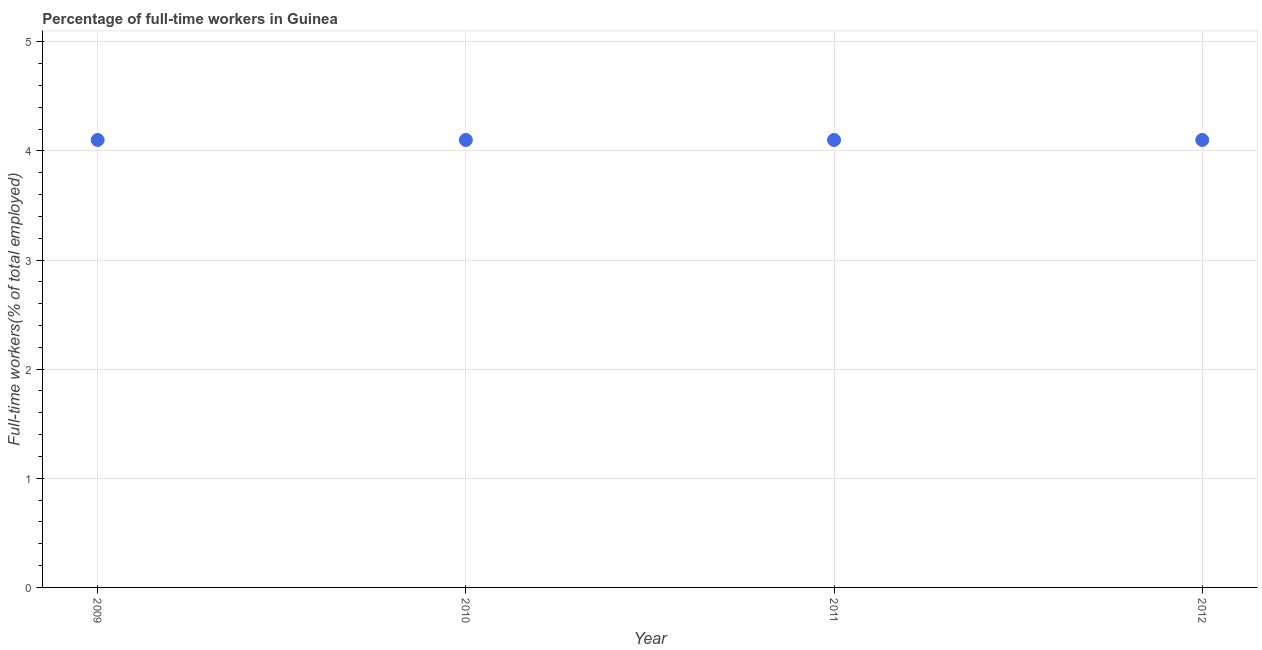What is the percentage of full-time workers in 2011?
Give a very brief answer. 4.1. Across all years, what is the maximum percentage of full-time workers?
Your answer should be compact. 4.1. Across all years, what is the minimum percentage of full-time workers?
Give a very brief answer. 4.1. What is the sum of the percentage of full-time workers?
Provide a short and direct response. 16.4. What is the average percentage of full-time workers per year?
Offer a terse response. 4.1. What is the median percentage of full-time workers?
Ensure brevity in your answer.  4.1. What is the ratio of the percentage of full-time workers in 2009 to that in 2012?
Ensure brevity in your answer.  1. Is the difference between the percentage of full-time workers in 2010 and 2012 greater than the difference between any two years?
Offer a terse response. Yes. Is the sum of the percentage of full-time workers in 2010 and 2012 greater than the maximum percentage of full-time workers across all years?
Your response must be concise. Yes. How many dotlines are there?
Your answer should be very brief. 1. How many years are there in the graph?
Offer a terse response. 4. What is the difference between two consecutive major ticks on the Y-axis?
Your answer should be very brief. 1. Are the values on the major ticks of Y-axis written in scientific E-notation?
Your response must be concise. No. Does the graph contain any zero values?
Offer a terse response. No. Does the graph contain grids?
Ensure brevity in your answer.  Yes. What is the title of the graph?
Offer a very short reply. Percentage of full-time workers in Guinea. What is the label or title of the X-axis?
Offer a terse response. Year. What is the label or title of the Y-axis?
Keep it short and to the point. Full-time workers(% of total employed). What is the Full-time workers(% of total employed) in 2009?
Offer a very short reply. 4.1. What is the Full-time workers(% of total employed) in 2010?
Make the answer very short. 4.1. What is the Full-time workers(% of total employed) in 2011?
Keep it short and to the point. 4.1. What is the Full-time workers(% of total employed) in 2012?
Your answer should be compact. 4.1. What is the difference between the Full-time workers(% of total employed) in 2009 and 2012?
Provide a short and direct response. 0. What is the difference between the Full-time workers(% of total employed) in 2010 and 2012?
Offer a terse response. 0. What is the difference between the Full-time workers(% of total employed) in 2011 and 2012?
Your answer should be very brief. 0. What is the ratio of the Full-time workers(% of total employed) in 2009 to that in 2010?
Your answer should be compact. 1. What is the ratio of the Full-time workers(% of total employed) in 2009 to that in 2011?
Make the answer very short. 1. What is the ratio of the Full-time workers(% of total employed) in 2010 to that in 2011?
Provide a short and direct response. 1. 